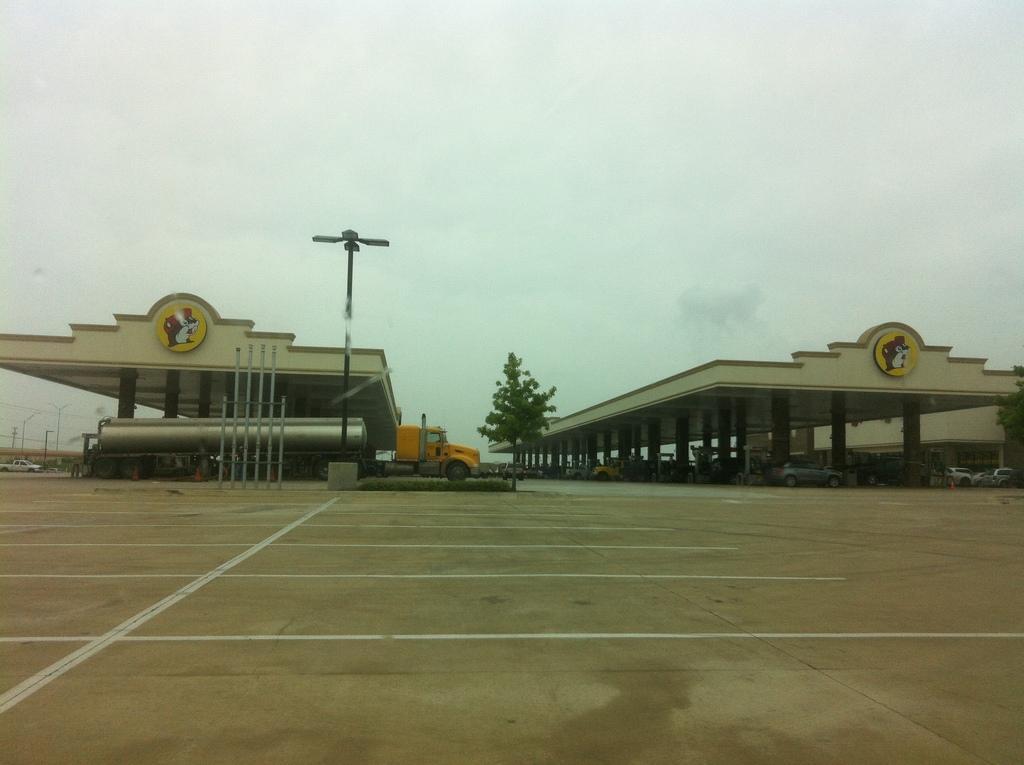In one or two sentences, can you explain what this image depicts? In this image I can see number of pillars, number of poles, two trees and number of vehicles. In the background I can see clouds and the sky. In the front I can see number of white lines on the ground. 